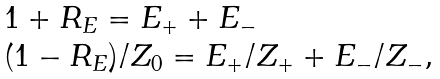<formula> <loc_0><loc_0><loc_500><loc_500>\begin{array} { l } 1 + R _ { E } = E _ { + } + E _ { - } \\ ( 1 - R _ { E } ) / Z _ { 0 } = E _ { + } / Z _ { + } + E _ { - } / Z _ { - } , \end{array}</formula> 